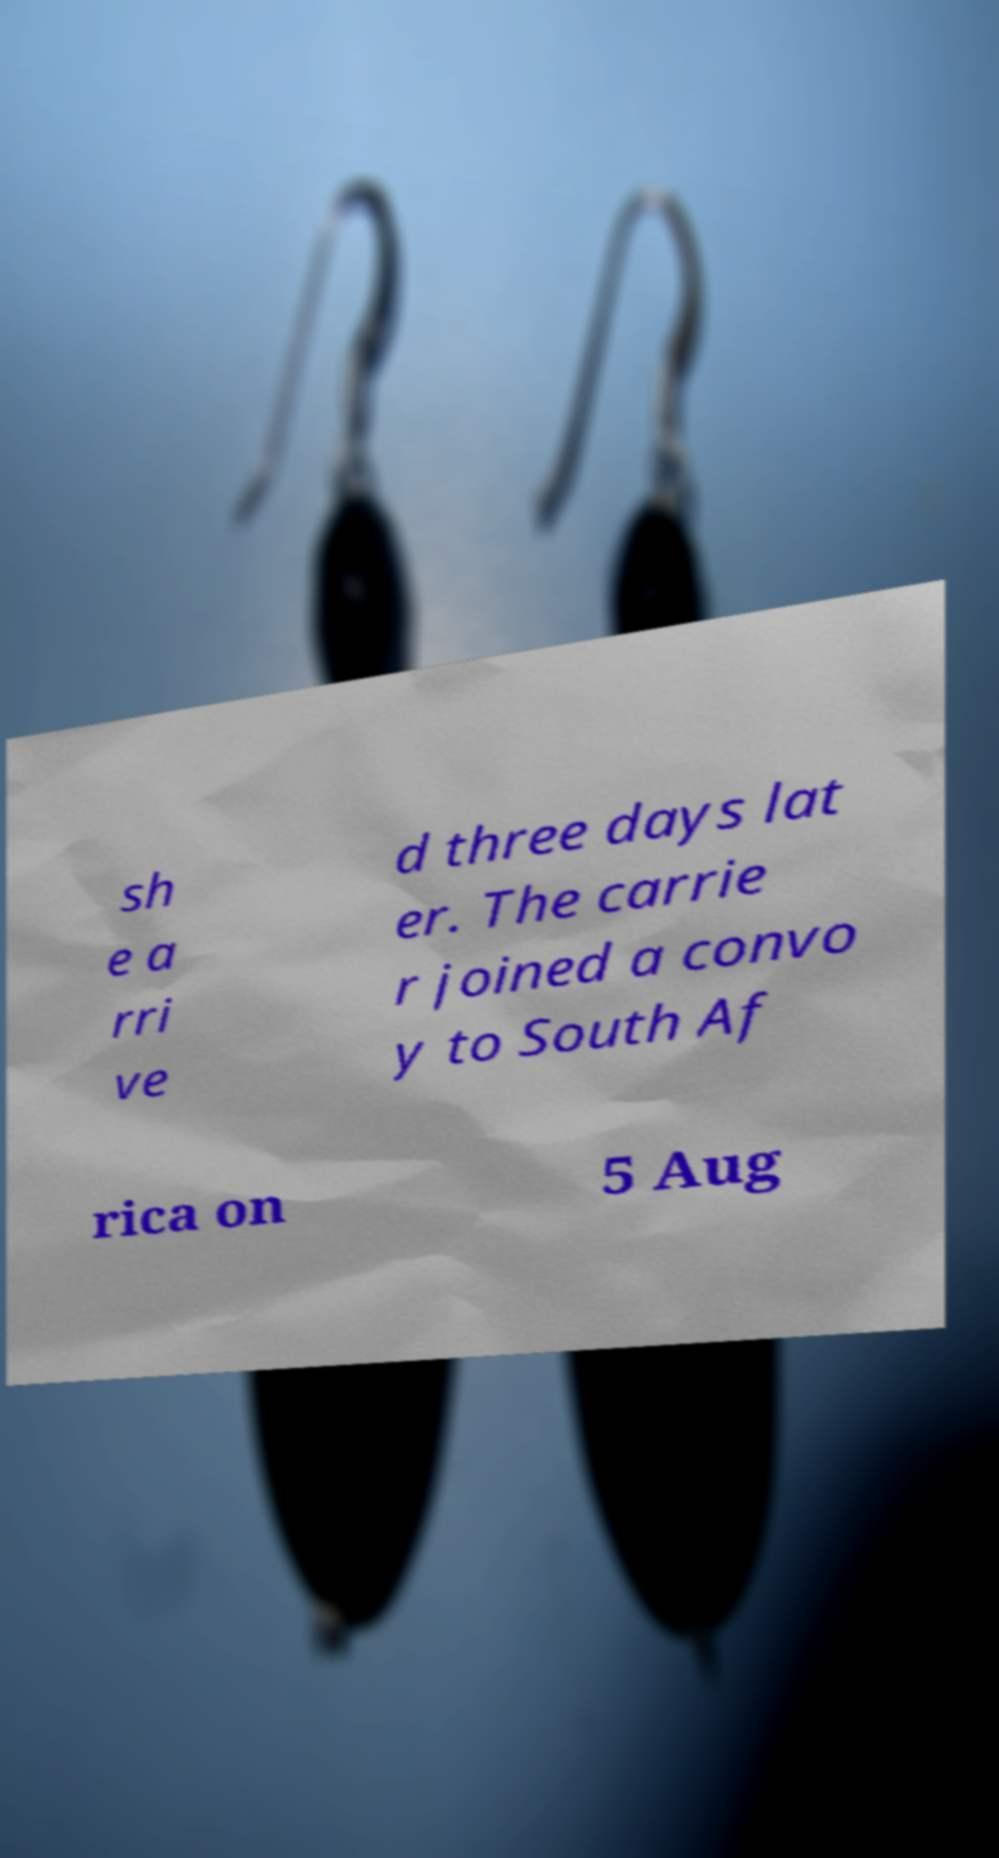There's text embedded in this image that I need extracted. Can you transcribe it verbatim? sh e a rri ve d three days lat er. The carrie r joined a convo y to South Af rica on 5 Aug 